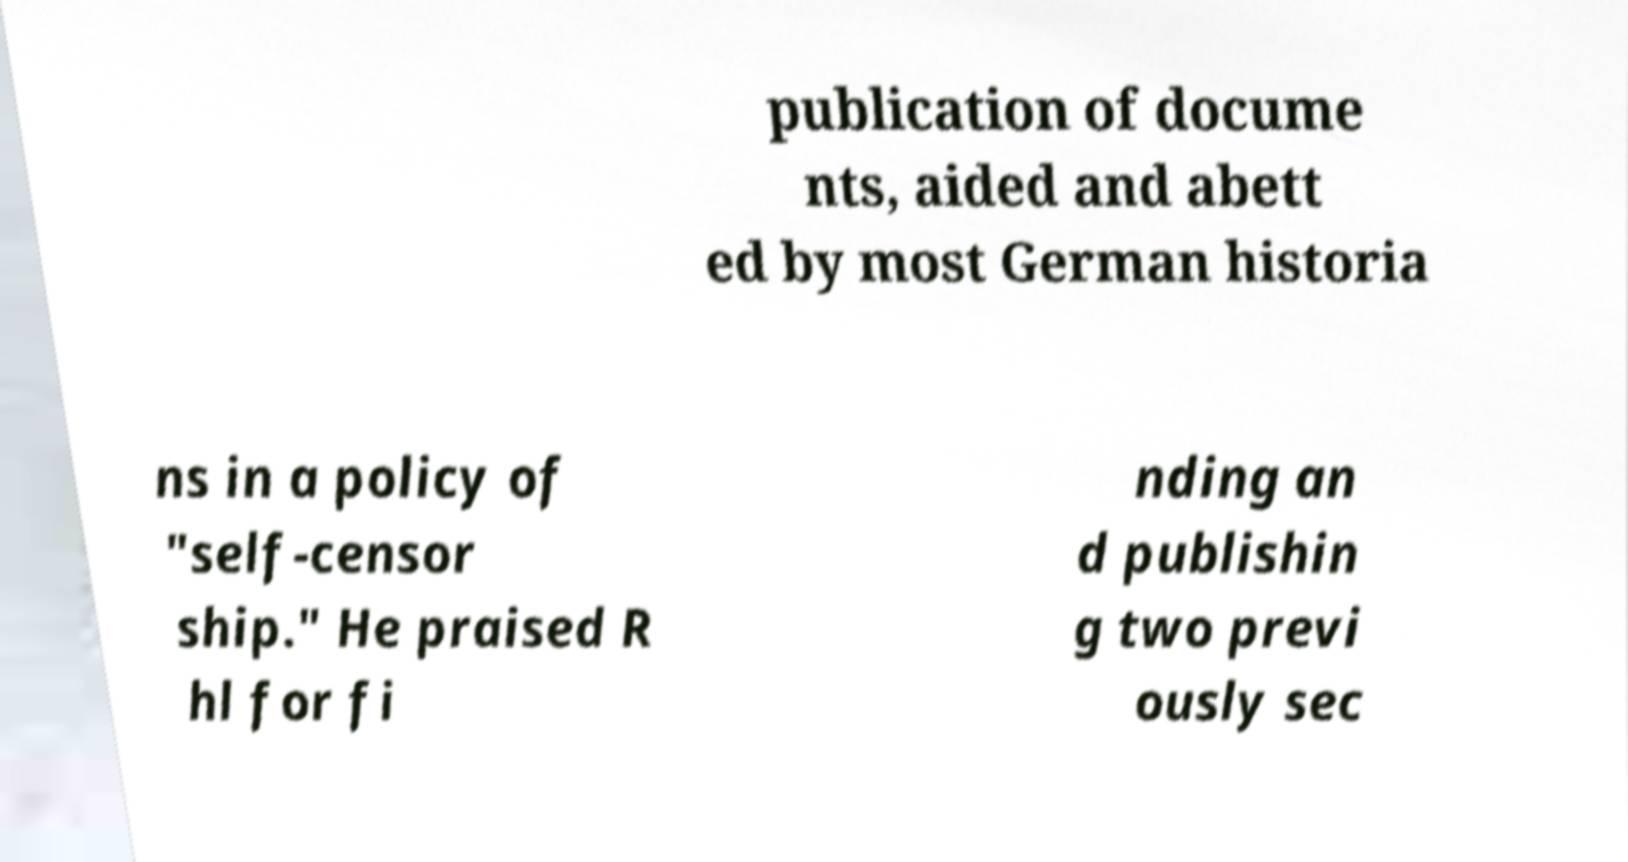There's text embedded in this image that I need extracted. Can you transcribe it verbatim? publication of docume nts, aided and abett ed by most German historia ns in a policy of "self-censor ship." He praised R hl for fi nding an d publishin g two previ ously sec 